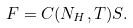Convert formula to latex. <formula><loc_0><loc_0><loc_500><loc_500>F = C ( N _ { H } , T ) S .</formula> 